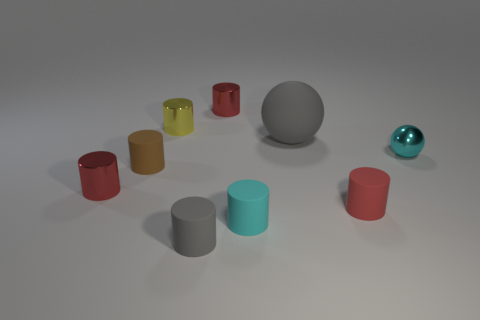What number of small objects have the same shape as the big gray matte thing?
Provide a succinct answer. 1. There is a cylinder on the left side of the rubber cylinder behind the tiny red thing that is on the right side of the large gray object; what color is it?
Ensure brevity in your answer.  Red. Are the cyan object that is on the right side of the red rubber cylinder and the red object that is on the left side of the tiny gray matte object made of the same material?
Offer a terse response. Yes. How many things are matte things that are to the right of the brown object or small brown metallic cubes?
Keep it short and to the point. 4. How many objects are either large green matte blocks or red cylinders that are in front of the tiny yellow cylinder?
Offer a terse response. 2. How many cyan shiny objects are the same size as the yellow thing?
Offer a very short reply. 1. Is the number of small things behind the tiny brown matte object less than the number of matte things to the left of the small gray cylinder?
Give a very brief answer. No. What number of shiny things are either gray balls or red cylinders?
Offer a very short reply. 2. There is a small cyan rubber thing; what shape is it?
Ensure brevity in your answer.  Cylinder. What material is the gray cylinder that is the same size as the cyan matte cylinder?
Keep it short and to the point. Rubber. 